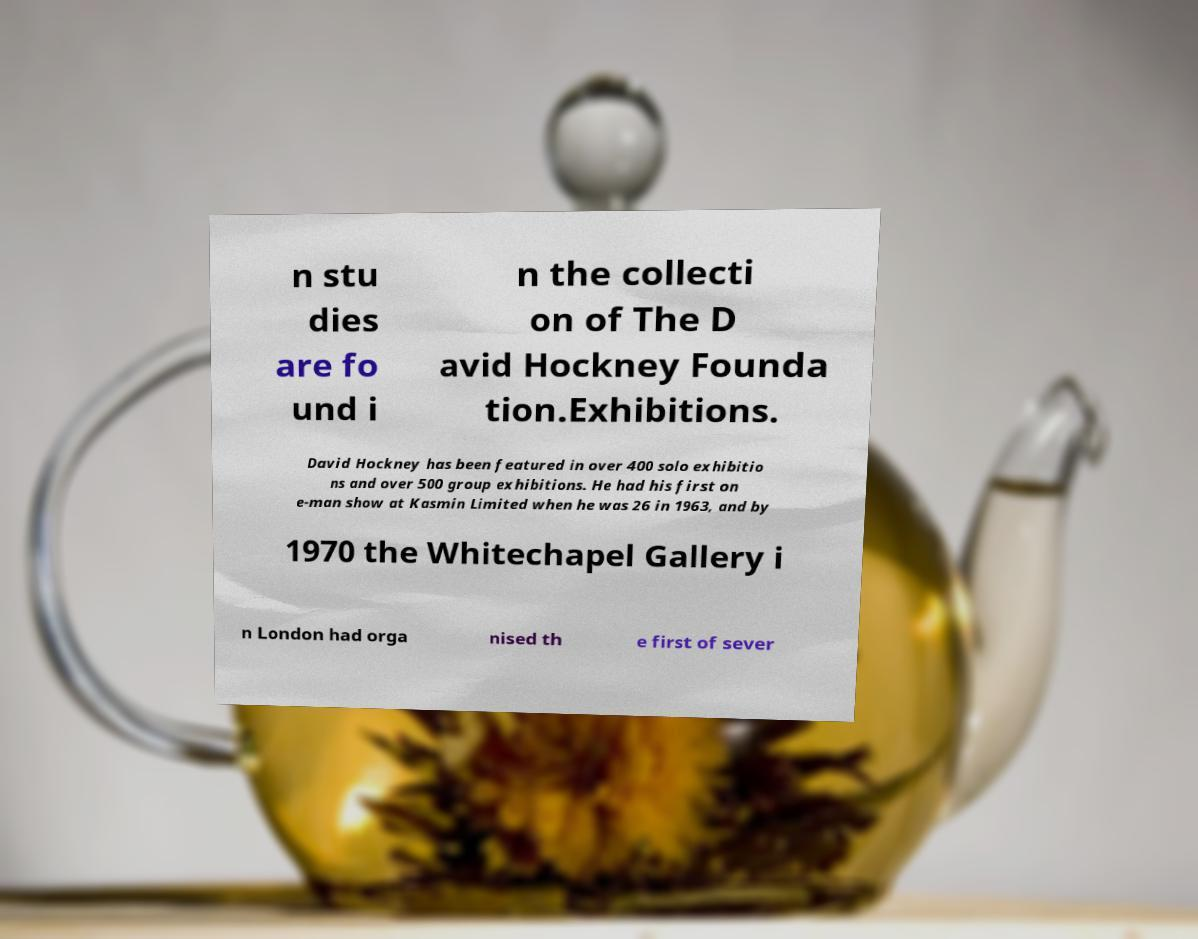Can you accurately transcribe the text from the provided image for me? n stu dies are fo und i n the collecti on of The D avid Hockney Founda tion.Exhibitions. David Hockney has been featured in over 400 solo exhibitio ns and over 500 group exhibitions. He had his first on e-man show at Kasmin Limited when he was 26 in 1963, and by 1970 the Whitechapel Gallery i n London had orga nised th e first of sever 